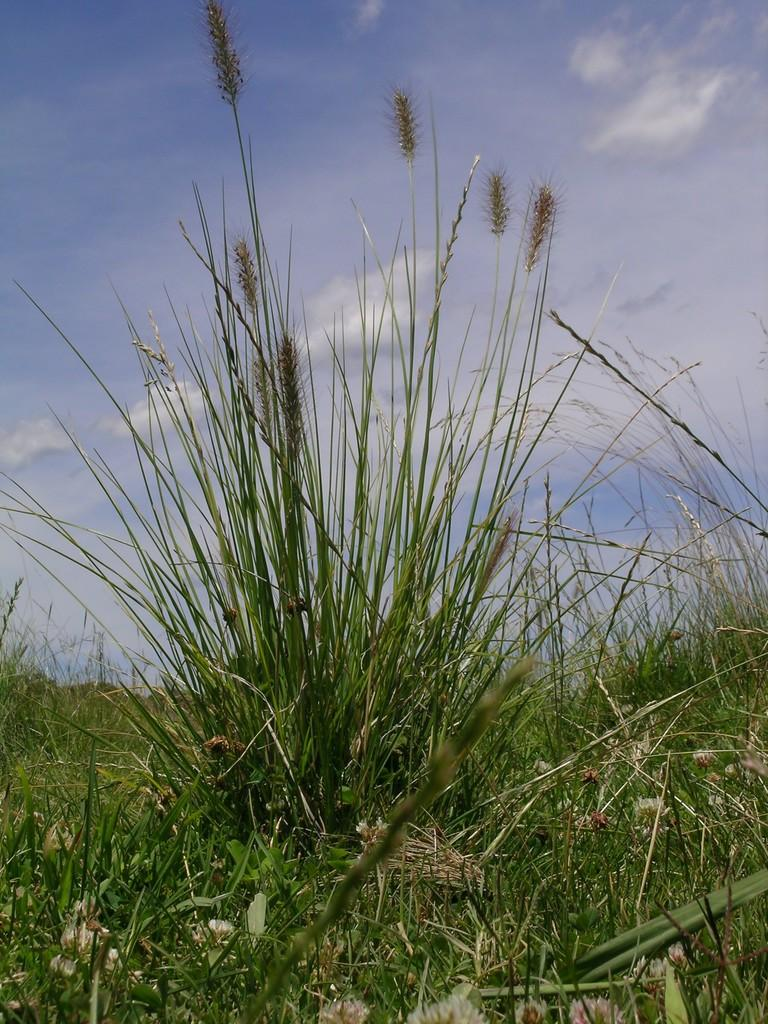What type of natural environment is visible at the bottom of the image? There is grass visible at the bottom of the image. What part of the natural environment is visible at the top of the image? The sky is visible at the top of the image. What type of mass is present in the image? There is no reference to any mass in the image; it simply features grass and the sky. Does the existence of the grass and sky in the image imply the existence of a society? The presence of grass and sky in the image does not necessarily imply the existence of a society, as these elements can be found in various natural environments. 